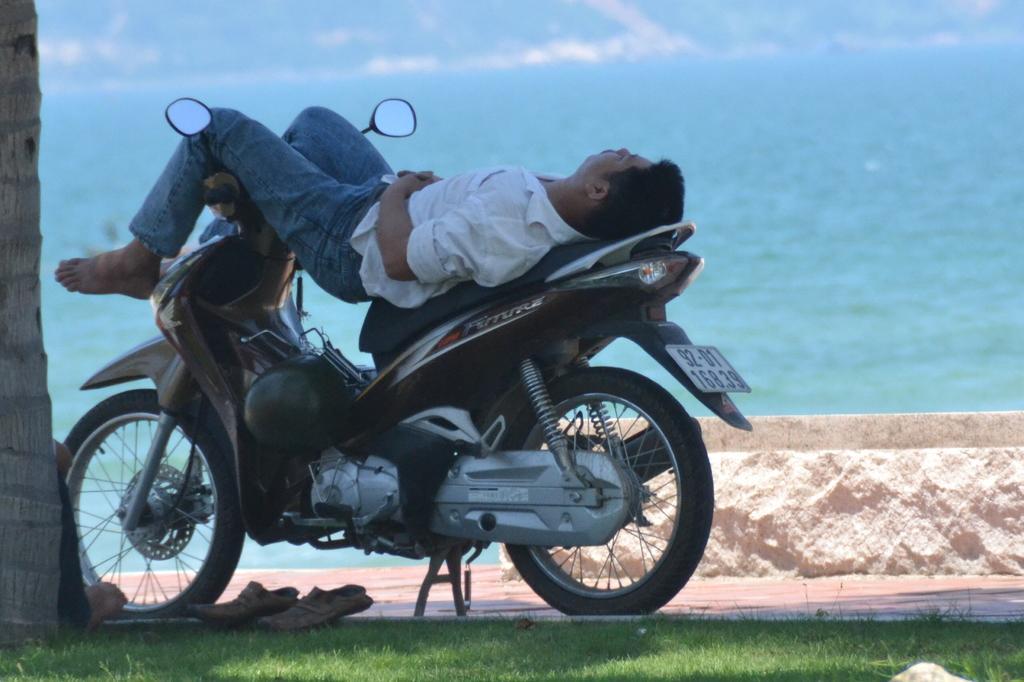In one or two sentences, can you explain what this image depicts? As we can see in the image there are water, grass and a man laying on scooty. 